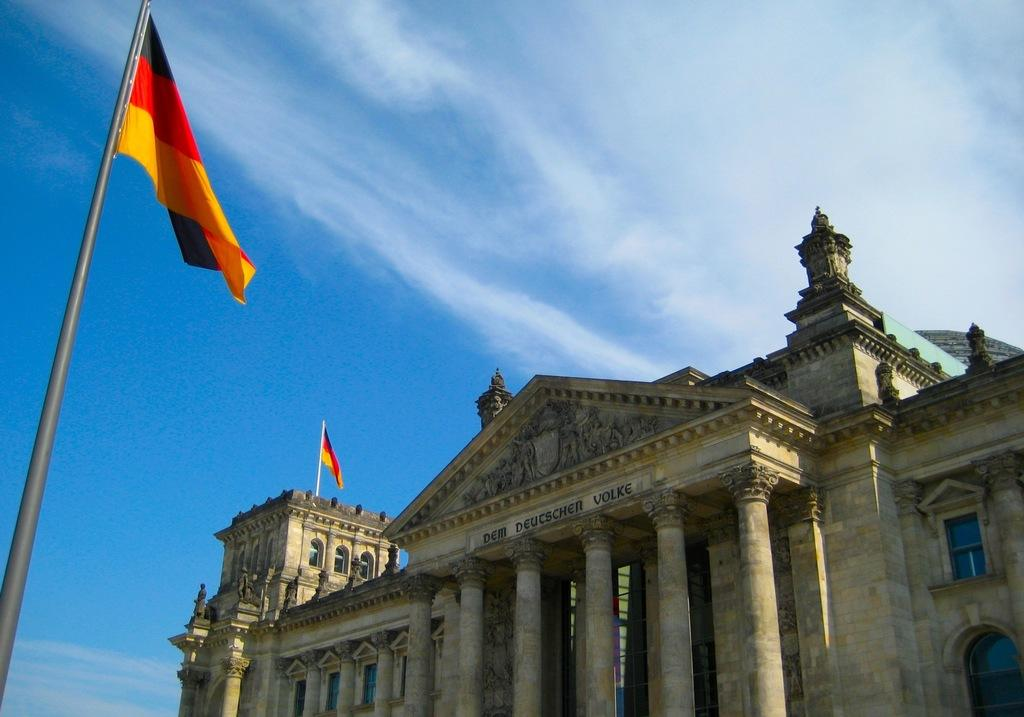What type of structure is visible in the image? There is a building with pillars in the image. What can be seen attached to the building or poles? There are flags in the image. What are the poles used for in the image? The poles are used to hold the flags. What is visible in the background of the image? The sky is visible in the image. What can be observed in the sky? Clouds are present in the sky. What type of jeans are visible in the image? There are no jeans present in the image. 